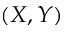<formula> <loc_0><loc_0><loc_500><loc_500>( X , Y )</formula> 